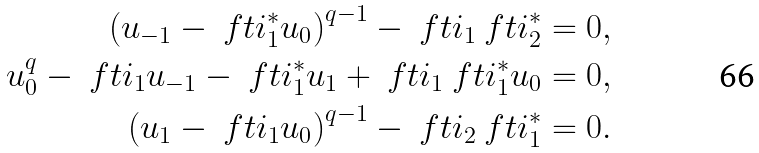<formula> <loc_0><loc_0><loc_500><loc_500>\left ( u _ { - 1 } - \ f t i _ { 1 } ^ { * } u _ { 0 } \right ) ^ { q - 1 } - \ f t i _ { 1 } \ f t i ^ { * } _ { 2 } & = 0 , \\ u _ { 0 } ^ { q } - \ f t i _ { 1 } u _ { - 1 } - \ f t i _ { 1 } ^ { * } u _ { 1 } + \ f t i _ { 1 } \ f t i _ { 1 } ^ { * } u _ { 0 } & = 0 , \\ \left ( u _ { 1 } - \ f t i _ { 1 } u _ { 0 } \right ) ^ { q - 1 } - \ f t i _ { 2 } \ f t i _ { 1 } ^ { * } & = 0 .</formula> 